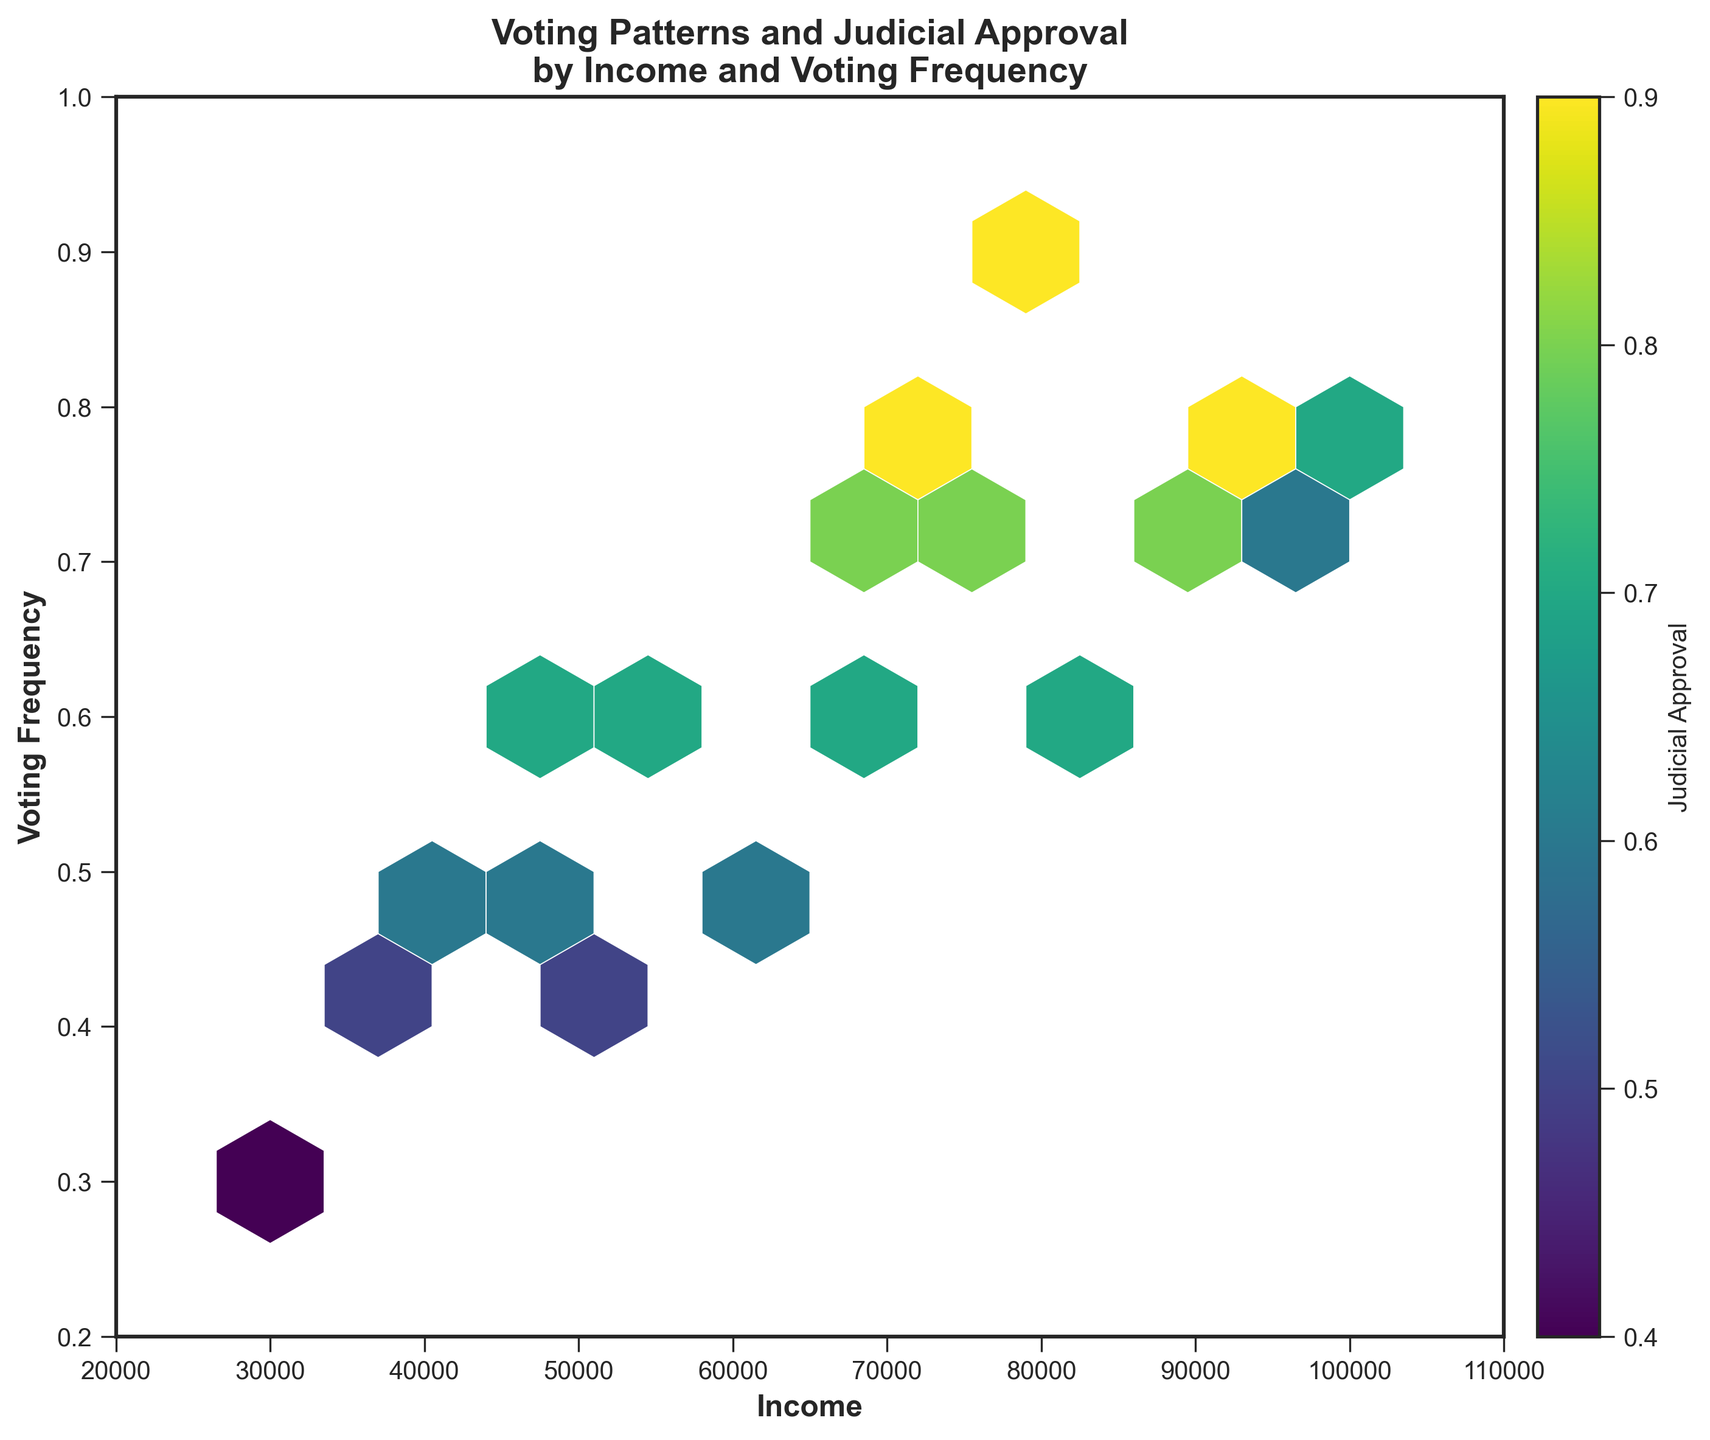What is the title of the figure? The title is often displayed at the top of the plot. This figure's title is "Voting Patterns and Judicial Approval by Income and Voting Frequency."
Answer: Voting Patterns and Judicial Approval by Income and Voting Frequency What variables are represented on the x-axis and y-axis? The x-axis label indicates "Income," and the y-axis label shows "Voting Frequency." Hence, the x-axis represents income levels, and the y-axis represents voting frequency.
Answer: Income and Voting Frequency What does the color indicate in the hexbin plot? The color bar on the plot indicates "Judicial Approval." Therefore, varying colors represent different levels of judicial approval.
Answer: Judicial Approval Which income range has the highest density of data points for medium voting frequency? Observing the plot, the densest region for a medium voting frequency (around 0.6) falls in the income range of approximately 40,000 to 70,000.
Answer: 40,000 to 70,000 Is there an area that shows high voting frequency and high judicial approval? To identify this, we look for areas with warmer colors (towards yellow) and high placement on the y-axis (closer to 1.0). This is observed in the region around 80,000 to 100,000 income and 0.8 voting frequency.
Answer: Yes, around 80,000 to 100,000 income and 0.8 voting frequency How does the voting frequency trend with increasing income? Generally, observing the plot, as income increases, various voting frequencies are present, but there is a gradual increase in density towards higher voting frequencies up to certain high income ranges.
Answer: Increases Which income group exhibits the broadest range of voting frequencies? Examining the spread along the y-axis for different income groups, the income range from 40,000 to 60,000 demonstrates the broadest range of voting frequencies.
Answer: 40,000 to 60,000 What is the relationship between voting frequency and judicial approval at low income levels? Low income levels (below 40,000) show varying voting frequencies, but the color indicates lower judicial approval across these voting frequencies.
Answer: Lower judicial approval Is there any income range with high voting frequency but low judicial approval? A high voting frequency with lower colors (indicative of low judicial approval) can be seen around the income range of 35,000 to 50,000.
Answer: Yes, around 35,000 to 50,000 What engine settings were used to create the plot? Since plot style and settings are coded, they are not visible in the figure. Instead, visual elements like grids, the color bar, and hexagon edges provide insights into constructed bins and density measurements.
Answer: Not applicable 